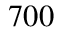<formula> <loc_0><loc_0><loc_500><loc_500>7 0 0</formula> 